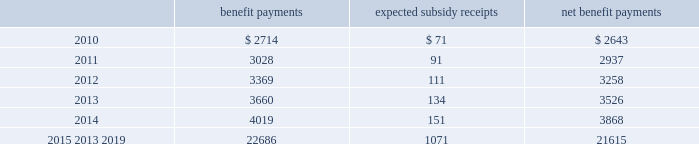Mastercard incorporated notes to consolidated financial statements 2014 ( continued ) ( in thousands , except percent and per share data ) the company does not make any contributions to its postretirement plan other than funding benefits payments .
The table summarizes expected net benefit payments from the company 2019s general assets through 2019 : benefit payments expected subsidy receipts benefit payments .
The company provides limited postemployment benefits to eligible former u.s .
Employees , primarily severance under a formal severance plan ( the 201cseverance plan 201d ) .
The company accounts for severance expense by accruing the expected cost of the severance benefits expected to be provided to former employees after employment over their relevant service periods .
The company updates the assumptions in determining the severance accrual by evaluating the actual severance activity and long-term trends underlying the assumptions .
As a result of updating the assumptions , the company recorded incremental severance expense ( benefit ) related to the severance plan of $ 3471 , $ 2643 and $ ( 3418 ) , respectively , during the years 2009 , 2008 and 2007 .
These amounts were part of total severance expenses of $ 135113 , $ 32997 and $ 21284 in 2009 , 2008 and 2007 , respectively , included in general and administrative expenses in the accompanying consolidated statements of operations .
Note 14 .
Debt on april 28 , 2008 , the company extended its committed unsecured revolving credit facility , dated as of april 28 , 2006 ( the 201ccredit facility 201d ) , for an additional year .
The new expiration date of the credit facility is april 26 , 2011 .
The available funding under the credit facility will remain at $ 2500000 through april 27 , 2010 and then decrease to $ 2000000 during the final year of the credit facility agreement .
Other terms and conditions in the credit facility remain unchanged .
The company 2019s option to request that each lender under the credit facility extend its commitment was provided pursuant to the original terms of the credit facility agreement .
Borrowings under the facility are available to provide liquidity in the event of one or more settlement failures by mastercard international customers and , subject to a limit of $ 500000 , for general corporate purposes .
The facility fee and borrowing cost are contingent upon the company 2019s credit rating .
At december 31 , 2009 , the facility fee was 7 basis points on the total commitment , or approximately $ 1774 annually .
Interest on borrowings under the credit facility would be charged at the london interbank offered rate ( libor ) plus an applicable margin of 28 basis points or an alternative base rate , and a utilization fee of 10 basis points would be charged if outstanding borrowings under the facility exceed 50% ( 50 % ) of commitments .
At the inception of the credit facility , the company also agreed to pay upfront fees of $ 1250 and administrative fees of $ 325 , which are being amortized over five years .
Facility and other fees associated with the credit facility totaled $ 2222 , $ 2353 and $ 2477 for each of the years ended december 31 , 2009 , 2008 and 2007 , respectively .
Mastercard was in compliance with the covenants of the credit facility and had no borrowings under the credit facility at december 31 , 2009 or december 31 , 2008 .
The majority of credit facility lenders are members or affiliates of members of mastercard international .
In june 1998 , mastercard international issued ten-year unsecured , subordinated notes ( the 201cnotes 201d ) paying a fixed interest rate of 6.67% ( 6.67 % ) per annum .
Mastercard repaid the entire principal amount of $ 80000 on june 30 , 2008 pursuant to the terms of the notes .
The interest expense on the notes was $ 2668 and $ 5336 for each of the years ended december 31 , 2008 and 2007 , respectively. .
What is the growth observed in the benefit payments during 2011 and 2012? 
Rationale: it is the value of benefit payments in 2012 divided by the 2011's , then transformed into a percentage to represent the increase .
Computations: ((3369 / 3028) - 1)
Answer: 0.11262. 